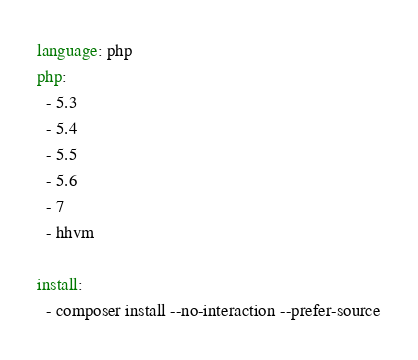Convert code to text. <code><loc_0><loc_0><loc_500><loc_500><_YAML_>language: php
php:
  - 5.3
  - 5.4
  - 5.5
  - 5.6
  - 7
  - hhvm

install:
  - composer install --no-interaction --prefer-source
</code> 